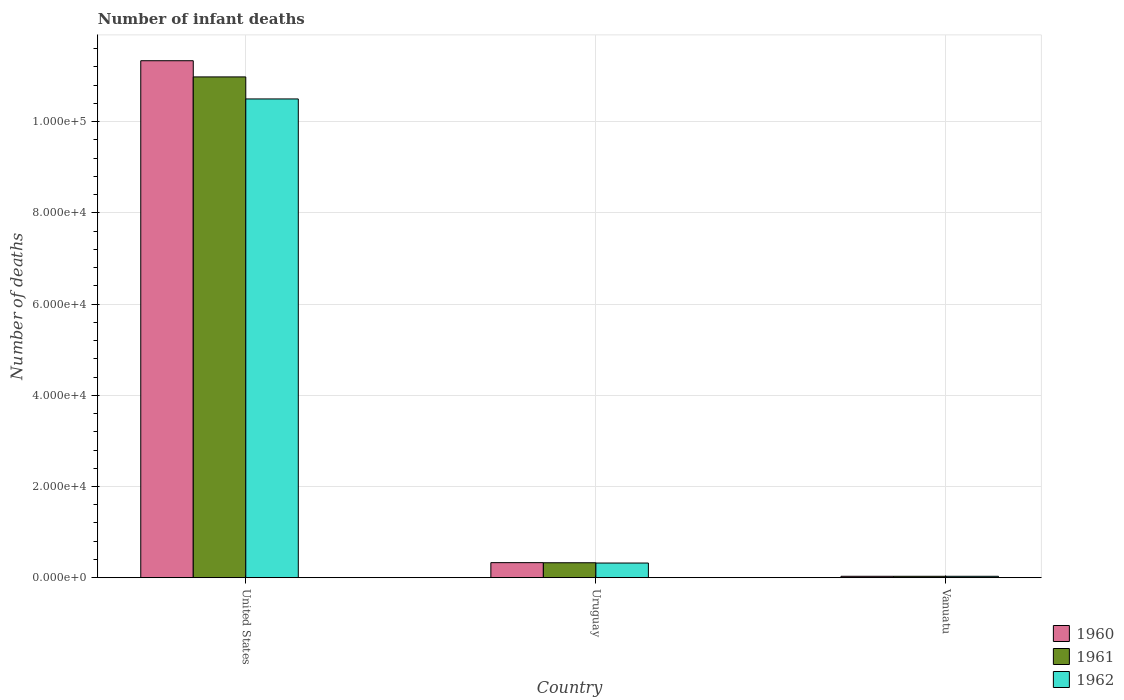Are the number of bars per tick equal to the number of legend labels?
Offer a terse response. Yes. Are the number of bars on each tick of the X-axis equal?
Ensure brevity in your answer.  Yes. What is the label of the 3rd group of bars from the left?
Your response must be concise. Vanuatu. What is the number of infant deaths in 1961 in Uruguay?
Provide a succinct answer. 3277. Across all countries, what is the maximum number of infant deaths in 1962?
Your answer should be compact. 1.05e+05. Across all countries, what is the minimum number of infant deaths in 1961?
Your answer should be very brief. 311. In which country was the number of infant deaths in 1961 maximum?
Keep it short and to the point. United States. In which country was the number of infant deaths in 1961 minimum?
Your response must be concise. Vanuatu. What is the total number of infant deaths in 1962 in the graph?
Provide a short and direct response. 1.09e+05. What is the difference between the number of infant deaths in 1960 in Uruguay and that in Vanuatu?
Offer a terse response. 2990. What is the difference between the number of infant deaths in 1961 in Vanuatu and the number of infant deaths in 1962 in Uruguay?
Your response must be concise. -2905. What is the average number of infant deaths in 1962 per country?
Provide a short and direct response. 3.62e+04. What is the difference between the number of infant deaths of/in 1961 and number of infant deaths of/in 1960 in United States?
Your response must be concise. -3550. In how many countries, is the number of infant deaths in 1962 greater than 72000?
Offer a terse response. 1. What is the ratio of the number of infant deaths in 1961 in Uruguay to that in Vanuatu?
Give a very brief answer. 10.54. What is the difference between the highest and the second highest number of infant deaths in 1962?
Keep it short and to the point. -1.02e+05. What is the difference between the highest and the lowest number of infant deaths in 1960?
Give a very brief answer. 1.13e+05. In how many countries, is the number of infant deaths in 1961 greater than the average number of infant deaths in 1961 taken over all countries?
Offer a very short reply. 1. Is the sum of the number of infant deaths in 1961 in Uruguay and Vanuatu greater than the maximum number of infant deaths in 1962 across all countries?
Provide a succinct answer. No. What does the 3rd bar from the right in Uruguay represents?
Keep it short and to the point. 1960. Is it the case that in every country, the sum of the number of infant deaths in 1962 and number of infant deaths in 1960 is greater than the number of infant deaths in 1961?
Provide a succinct answer. Yes. Are all the bars in the graph horizontal?
Offer a very short reply. No. Does the graph contain any zero values?
Provide a short and direct response. No. Where does the legend appear in the graph?
Provide a succinct answer. Bottom right. How many legend labels are there?
Your response must be concise. 3. How are the legend labels stacked?
Offer a very short reply. Vertical. What is the title of the graph?
Your answer should be very brief. Number of infant deaths. What is the label or title of the X-axis?
Offer a terse response. Country. What is the label or title of the Y-axis?
Give a very brief answer. Number of deaths. What is the Number of deaths of 1960 in United States?
Offer a terse response. 1.13e+05. What is the Number of deaths of 1961 in United States?
Your answer should be compact. 1.10e+05. What is the Number of deaths in 1962 in United States?
Make the answer very short. 1.05e+05. What is the Number of deaths in 1960 in Uruguay?
Ensure brevity in your answer.  3301. What is the Number of deaths of 1961 in Uruguay?
Your answer should be compact. 3277. What is the Number of deaths in 1962 in Uruguay?
Your answer should be compact. 3216. What is the Number of deaths of 1960 in Vanuatu?
Your answer should be compact. 311. What is the Number of deaths in 1961 in Vanuatu?
Keep it short and to the point. 311. What is the Number of deaths in 1962 in Vanuatu?
Give a very brief answer. 311. Across all countries, what is the maximum Number of deaths in 1960?
Provide a succinct answer. 1.13e+05. Across all countries, what is the maximum Number of deaths of 1961?
Your answer should be compact. 1.10e+05. Across all countries, what is the maximum Number of deaths in 1962?
Give a very brief answer. 1.05e+05. Across all countries, what is the minimum Number of deaths in 1960?
Your response must be concise. 311. Across all countries, what is the minimum Number of deaths in 1961?
Provide a short and direct response. 311. Across all countries, what is the minimum Number of deaths of 1962?
Make the answer very short. 311. What is the total Number of deaths in 1960 in the graph?
Your response must be concise. 1.17e+05. What is the total Number of deaths of 1961 in the graph?
Your answer should be very brief. 1.13e+05. What is the total Number of deaths of 1962 in the graph?
Provide a succinct answer. 1.09e+05. What is the difference between the Number of deaths of 1960 in United States and that in Uruguay?
Offer a very short reply. 1.10e+05. What is the difference between the Number of deaths in 1961 in United States and that in Uruguay?
Provide a short and direct response. 1.07e+05. What is the difference between the Number of deaths in 1962 in United States and that in Uruguay?
Your answer should be compact. 1.02e+05. What is the difference between the Number of deaths in 1960 in United States and that in Vanuatu?
Provide a succinct answer. 1.13e+05. What is the difference between the Number of deaths in 1961 in United States and that in Vanuatu?
Offer a very short reply. 1.09e+05. What is the difference between the Number of deaths of 1962 in United States and that in Vanuatu?
Ensure brevity in your answer.  1.05e+05. What is the difference between the Number of deaths of 1960 in Uruguay and that in Vanuatu?
Give a very brief answer. 2990. What is the difference between the Number of deaths of 1961 in Uruguay and that in Vanuatu?
Make the answer very short. 2966. What is the difference between the Number of deaths of 1962 in Uruguay and that in Vanuatu?
Make the answer very short. 2905. What is the difference between the Number of deaths in 1960 in United States and the Number of deaths in 1961 in Uruguay?
Keep it short and to the point. 1.10e+05. What is the difference between the Number of deaths of 1960 in United States and the Number of deaths of 1962 in Uruguay?
Keep it short and to the point. 1.10e+05. What is the difference between the Number of deaths in 1961 in United States and the Number of deaths in 1962 in Uruguay?
Provide a succinct answer. 1.07e+05. What is the difference between the Number of deaths in 1960 in United States and the Number of deaths in 1961 in Vanuatu?
Ensure brevity in your answer.  1.13e+05. What is the difference between the Number of deaths of 1960 in United States and the Number of deaths of 1962 in Vanuatu?
Your response must be concise. 1.13e+05. What is the difference between the Number of deaths of 1961 in United States and the Number of deaths of 1962 in Vanuatu?
Provide a short and direct response. 1.09e+05. What is the difference between the Number of deaths of 1960 in Uruguay and the Number of deaths of 1961 in Vanuatu?
Keep it short and to the point. 2990. What is the difference between the Number of deaths of 1960 in Uruguay and the Number of deaths of 1962 in Vanuatu?
Provide a succinct answer. 2990. What is the difference between the Number of deaths in 1961 in Uruguay and the Number of deaths in 1962 in Vanuatu?
Your response must be concise. 2966. What is the average Number of deaths of 1960 per country?
Keep it short and to the point. 3.90e+04. What is the average Number of deaths of 1961 per country?
Offer a terse response. 3.78e+04. What is the average Number of deaths in 1962 per country?
Provide a succinct answer. 3.62e+04. What is the difference between the Number of deaths in 1960 and Number of deaths in 1961 in United States?
Your answer should be compact. 3550. What is the difference between the Number of deaths of 1960 and Number of deaths of 1962 in United States?
Ensure brevity in your answer.  8380. What is the difference between the Number of deaths of 1961 and Number of deaths of 1962 in United States?
Offer a terse response. 4830. What is the difference between the Number of deaths of 1960 and Number of deaths of 1961 in Vanuatu?
Ensure brevity in your answer.  0. What is the difference between the Number of deaths in 1960 and Number of deaths in 1962 in Vanuatu?
Your answer should be very brief. 0. What is the difference between the Number of deaths of 1961 and Number of deaths of 1962 in Vanuatu?
Ensure brevity in your answer.  0. What is the ratio of the Number of deaths of 1960 in United States to that in Uruguay?
Provide a short and direct response. 34.34. What is the ratio of the Number of deaths in 1961 in United States to that in Uruguay?
Your answer should be compact. 33.51. What is the ratio of the Number of deaths of 1962 in United States to that in Uruguay?
Offer a very short reply. 32.64. What is the ratio of the Number of deaths in 1960 in United States to that in Vanuatu?
Ensure brevity in your answer.  364.48. What is the ratio of the Number of deaths of 1961 in United States to that in Vanuatu?
Your response must be concise. 353.07. What is the ratio of the Number of deaths in 1962 in United States to that in Vanuatu?
Make the answer very short. 337.54. What is the ratio of the Number of deaths in 1960 in Uruguay to that in Vanuatu?
Offer a very short reply. 10.61. What is the ratio of the Number of deaths in 1961 in Uruguay to that in Vanuatu?
Give a very brief answer. 10.54. What is the ratio of the Number of deaths of 1962 in Uruguay to that in Vanuatu?
Your answer should be compact. 10.34. What is the difference between the highest and the second highest Number of deaths of 1960?
Give a very brief answer. 1.10e+05. What is the difference between the highest and the second highest Number of deaths in 1961?
Ensure brevity in your answer.  1.07e+05. What is the difference between the highest and the second highest Number of deaths in 1962?
Offer a very short reply. 1.02e+05. What is the difference between the highest and the lowest Number of deaths in 1960?
Your answer should be very brief. 1.13e+05. What is the difference between the highest and the lowest Number of deaths of 1961?
Make the answer very short. 1.09e+05. What is the difference between the highest and the lowest Number of deaths of 1962?
Ensure brevity in your answer.  1.05e+05. 